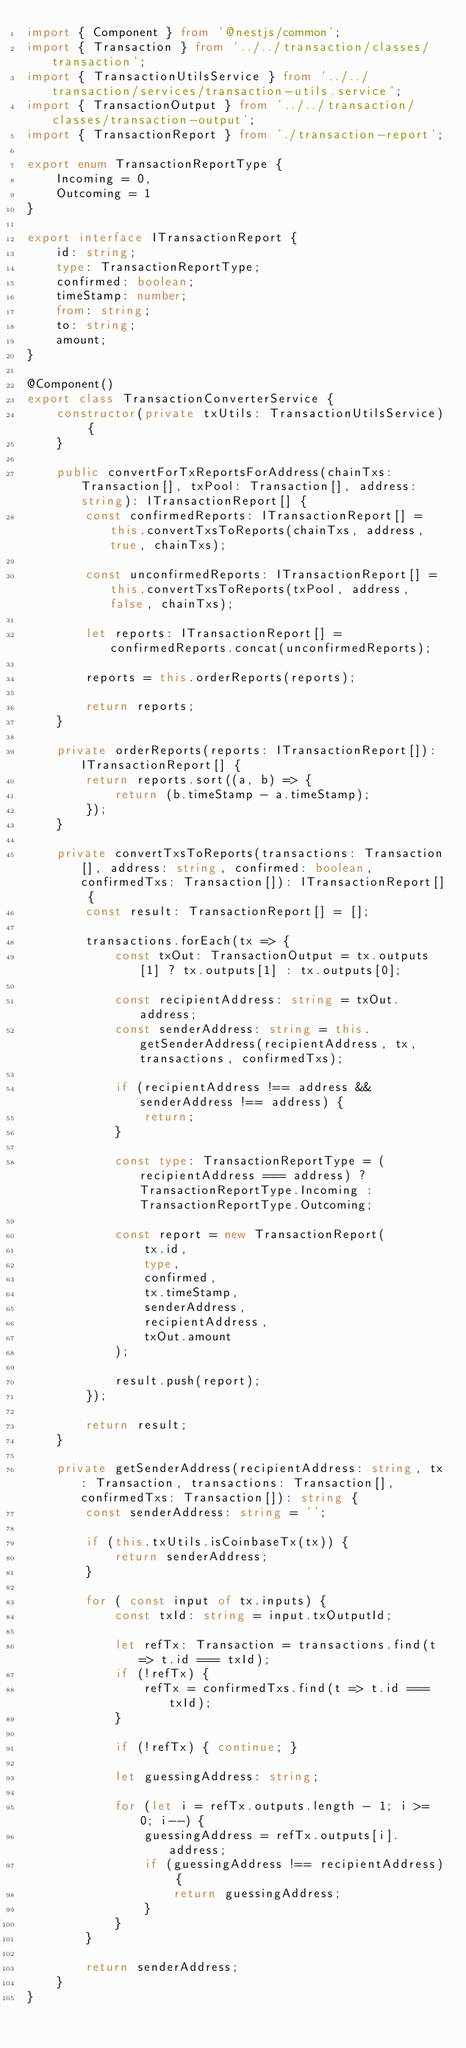Convert code to text. <code><loc_0><loc_0><loc_500><loc_500><_TypeScript_>import { Component } from '@nestjs/common';
import { Transaction } from '../../transaction/classes/transaction';
import { TransactionUtilsService } from '../../transaction/services/transaction-utils.service';
import { TransactionOutput } from '../../transaction/classes/transaction-output';
import { TransactionReport } from './transaction-report';

export enum TransactionReportType {
    Incoming = 0,
    Outcoming = 1
}

export interface ITransactionReport {
    id: string;
    type: TransactionReportType;
    confirmed: boolean;
    timeStamp: number;
    from: string;
    to: string;
    amount;
}

@Component()
export class TransactionConverterService {
    constructor(private txUtils: TransactionUtilsService) {
    }

    public convertForTxReportsForAddress(chainTxs: Transaction[], txPool: Transaction[], address: string): ITransactionReport[] {
        const confirmedReports: ITransactionReport[] = this.convertTxsToReports(chainTxs, address, true, chainTxs);

        const unconfirmedReports: ITransactionReport[] = this.convertTxsToReports(txPool, address, false, chainTxs);

        let reports: ITransactionReport[] = confirmedReports.concat(unconfirmedReports);

        reports = this.orderReports(reports);

        return reports;
    }

    private orderReports(reports: ITransactionReport[]): ITransactionReport[] {
        return reports.sort((a, b) => {
            return (b.timeStamp - a.timeStamp);
        });
    }

    private convertTxsToReports(transactions: Transaction[], address: string, confirmed: boolean, confirmedTxs: Transaction[]): ITransactionReport[] {
        const result: TransactionReport[] = [];

        transactions.forEach(tx => {
            const txOut: TransactionOutput = tx.outputs[1] ? tx.outputs[1] : tx.outputs[0];

            const recipientAddress: string = txOut.address;
            const senderAddress: string = this.getSenderAddress(recipientAddress, tx, transactions, confirmedTxs);

            if (recipientAddress !== address && senderAddress !== address) {
                return;
            }

            const type: TransactionReportType = (recipientAddress === address) ? TransactionReportType.Incoming : TransactionReportType.Outcoming;

            const report = new TransactionReport(
                tx.id,
                type,
                confirmed,
                tx.timeStamp,
                senderAddress,
                recipientAddress,
                txOut.amount
            );

            result.push(report);
        });

        return result;
    }

    private getSenderAddress(recipientAddress: string, tx: Transaction, transactions: Transaction[], confirmedTxs: Transaction[]): string {
        const senderAddress: string = '';

        if (this.txUtils.isCoinbaseTx(tx)) {
            return senderAddress;
        }

        for ( const input of tx.inputs) {
            const txId: string = input.txOutputId;

            let refTx: Transaction = transactions.find(t => t.id === txId);
            if (!refTx) {
                refTx = confirmedTxs.find(t => t.id === txId);
            }

            if (!refTx) { continue; }

            let guessingAddress: string;

            for (let i = refTx.outputs.length - 1; i >= 0; i--) {
                guessingAddress = refTx.outputs[i].address;
                if (guessingAddress !== recipientAddress) {
                    return guessingAddress;
                }
            }
        }

        return senderAddress;
    }
}</code> 